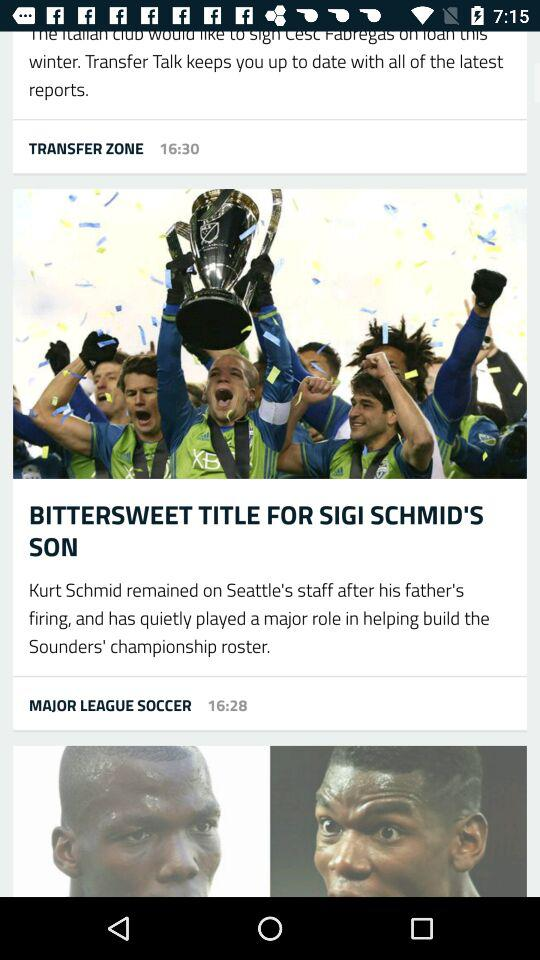What is the posted time of the images given under "MAJOR LEAGUE SOCCER"? The posted time of the images given under "MAJOR LEAGUE SOCCER" is 16:28. 